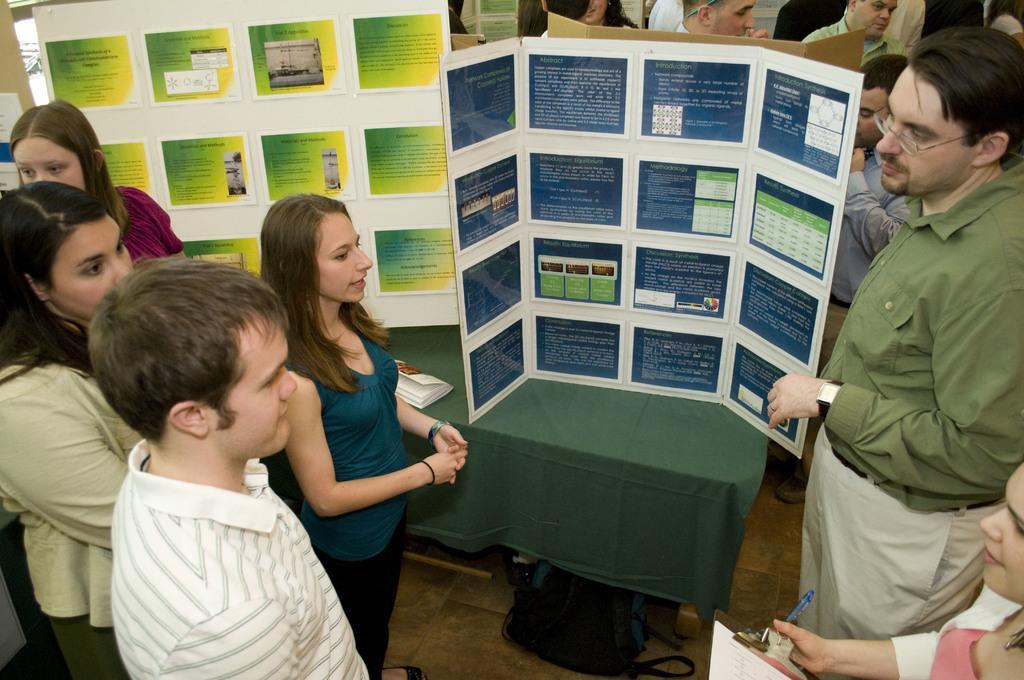In one or two sentences, can you explain what this image depicts? In this picture there is a man wearing green color t-shirt is giving a demonstration by showing the blue color poster. On the left side we can see some girls are standing and discussing something. Behind there is a white and green color poster with many photos. 